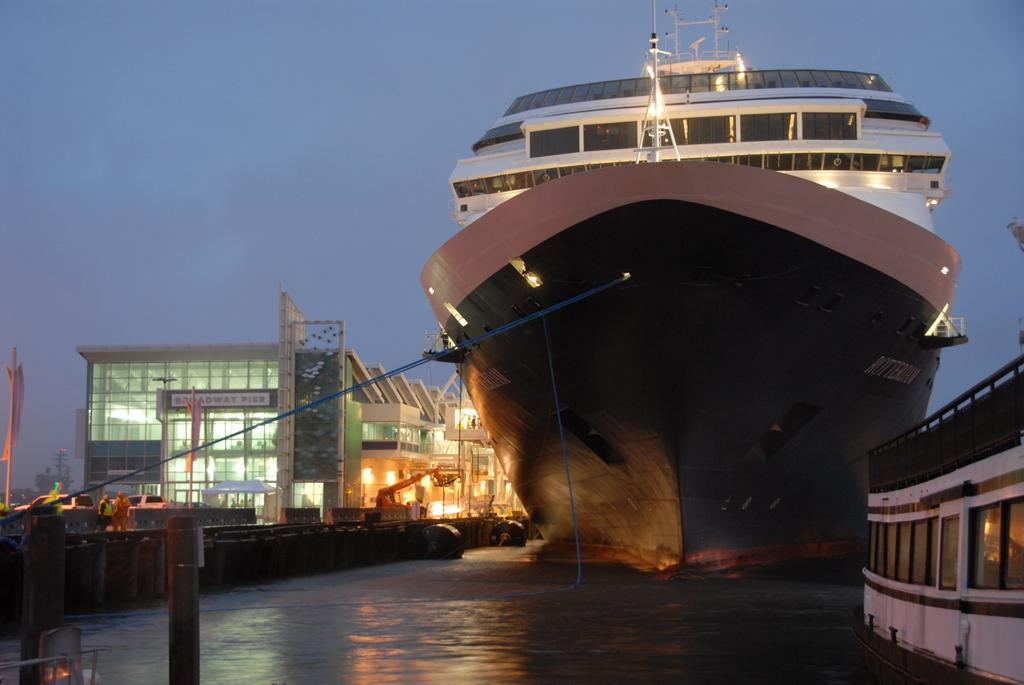<image>
Summarize the visual content of the image. A large ship is docked outside of Broadway Pier. 